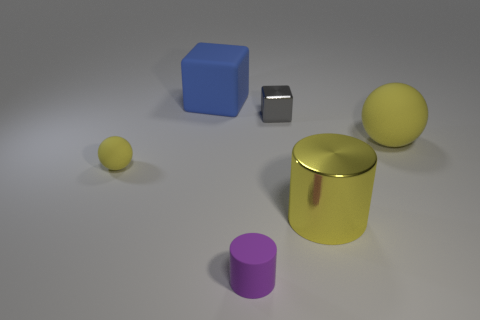How many objects are there in the image, and can you describe their shapes? There are five objects in the image. Starting from the left, there is a small yellow sphere, a medium-sized blue cube, a small metallic cube, a purple matte cylinder, and a large yellow cylinder with a glossy finish. 